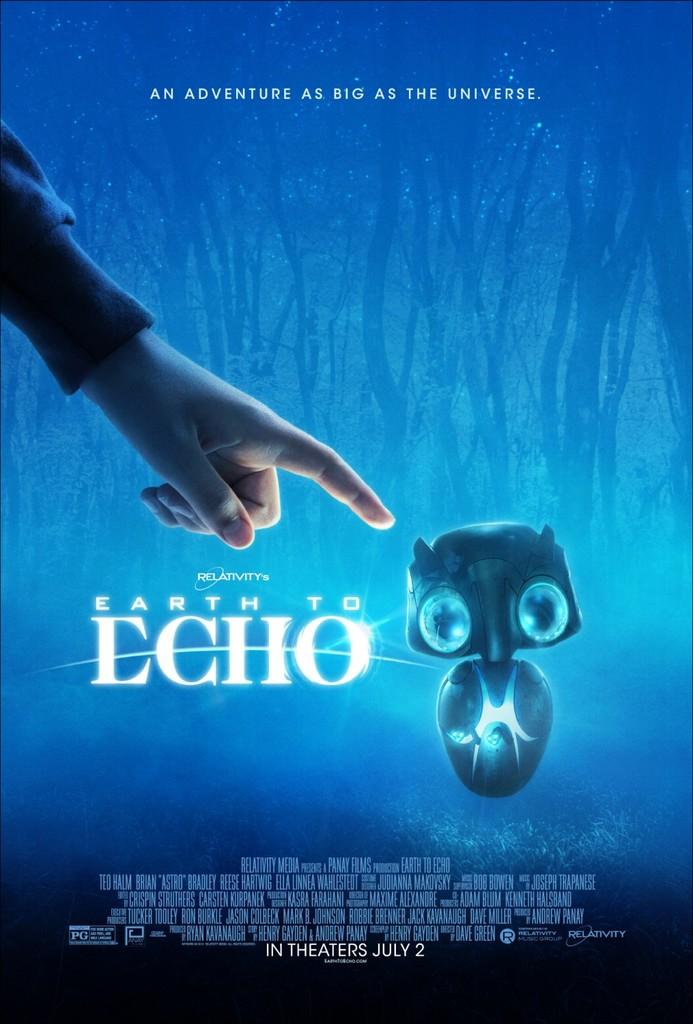What is the release date for earth to echo?
Keep it short and to the point. July 2. An adventure is as big as what?
Offer a terse response. The universe. 